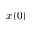Convert formula to latex. <formula><loc_0><loc_0><loc_500><loc_500>x ( 0 )</formula> 